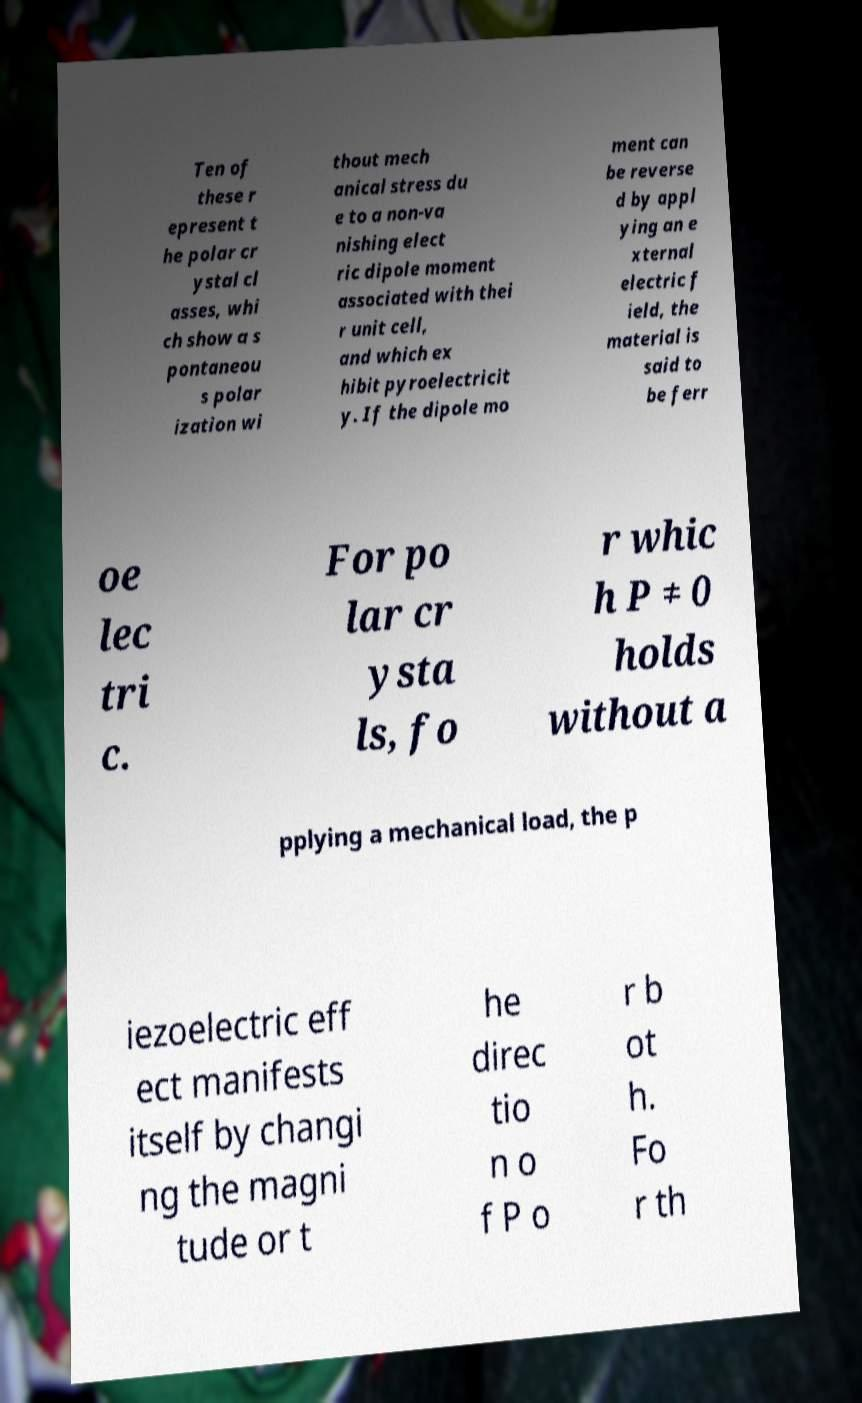Can you read and provide the text displayed in the image?This photo seems to have some interesting text. Can you extract and type it out for me? Ten of these r epresent t he polar cr ystal cl asses, whi ch show a s pontaneou s polar ization wi thout mech anical stress du e to a non-va nishing elect ric dipole moment associated with thei r unit cell, and which ex hibit pyroelectricit y. If the dipole mo ment can be reverse d by appl ying an e xternal electric f ield, the material is said to be ferr oe lec tri c. For po lar cr ysta ls, fo r whic h P ≠ 0 holds without a pplying a mechanical load, the p iezoelectric eff ect manifests itself by changi ng the magni tude or t he direc tio n o f P o r b ot h. Fo r th 